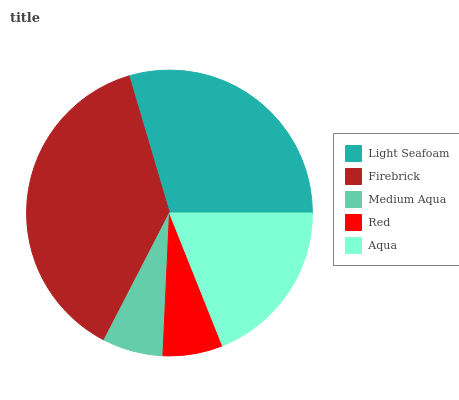Is Red the minimum?
Answer yes or no. Yes. Is Firebrick the maximum?
Answer yes or no. Yes. Is Medium Aqua the minimum?
Answer yes or no. No. Is Medium Aqua the maximum?
Answer yes or no. No. Is Firebrick greater than Medium Aqua?
Answer yes or no. Yes. Is Medium Aqua less than Firebrick?
Answer yes or no. Yes. Is Medium Aqua greater than Firebrick?
Answer yes or no. No. Is Firebrick less than Medium Aqua?
Answer yes or no. No. Is Aqua the high median?
Answer yes or no. Yes. Is Aqua the low median?
Answer yes or no. Yes. Is Red the high median?
Answer yes or no. No. Is Red the low median?
Answer yes or no. No. 